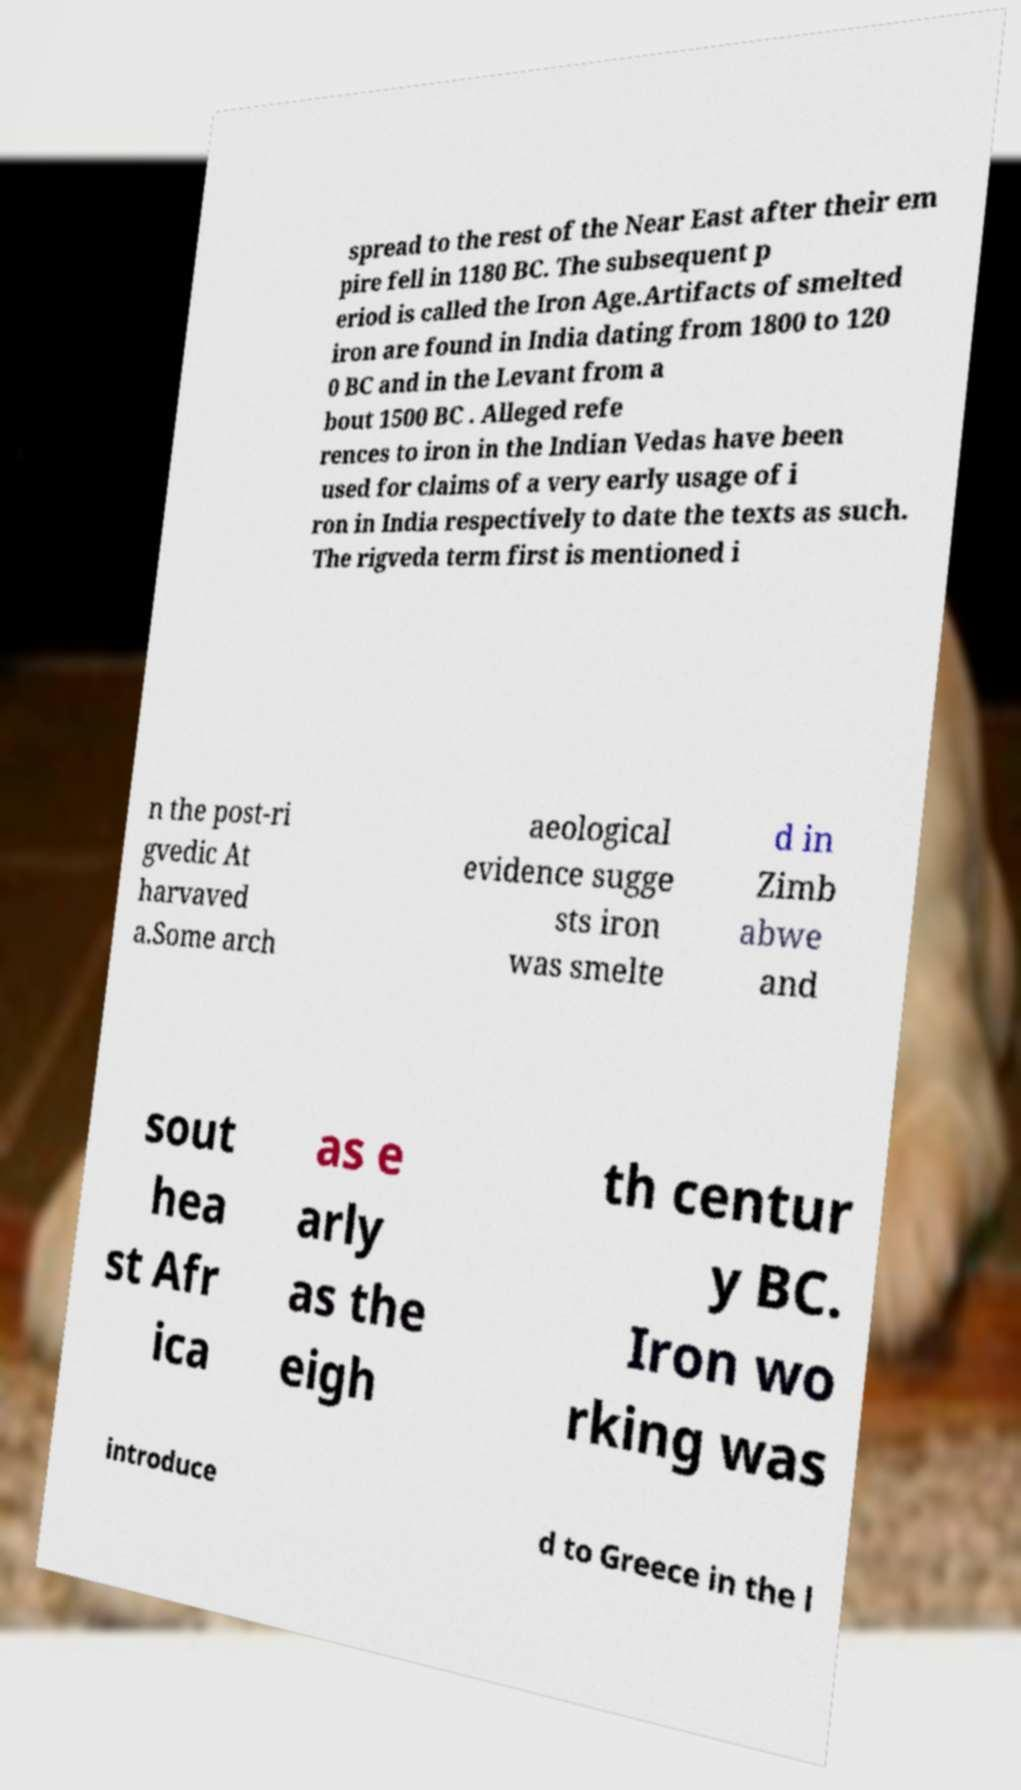What messages or text are displayed in this image? I need them in a readable, typed format. spread to the rest of the Near East after their em pire fell in 1180 BC. The subsequent p eriod is called the Iron Age.Artifacts of smelted iron are found in India dating from 1800 to 120 0 BC and in the Levant from a bout 1500 BC . Alleged refe rences to iron in the Indian Vedas have been used for claims of a very early usage of i ron in India respectively to date the texts as such. The rigveda term first is mentioned i n the post-ri gvedic At harvaved a.Some arch aeological evidence sugge sts iron was smelte d in Zimb abwe and sout hea st Afr ica as e arly as the eigh th centur y BC. Iron wo rking was introduce d to Greece in the l 